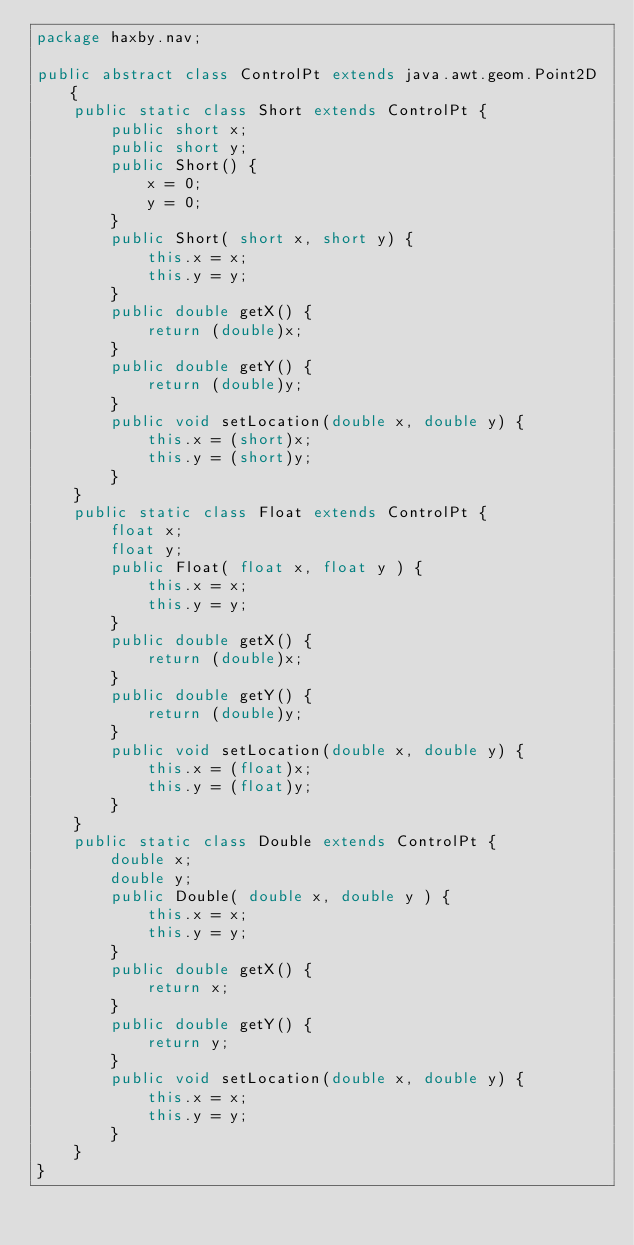Convert code to text. <code><loc_0><loc_0><loc_500><loc_500><_Java_>package haxby.nav;

public abstract class ControlPt extends java.awt.geom.Point2D {
	public static class Short extends ControlPt {
		public short x;
		public short y;
		public Short() {
			x = 0;
			y = 0;
		}
		public Short( short x, short y) {
			this.x = x;
			this.y = y;
		}
		public double getX() {
			return (double)x;
		}
		public double getY() {
			return (double)y;
		}
		public void setLocation(double x, double y) {
			this.x = (short)x;
			this.y = (short)y;
		}
	}
	public static class Float extends ControlPt {
		float x;
		float y;
		public Float( float x, float y ) {
			this.x = x;
			this.y = y;
		}
		public double getX() {
			return (double)x;
		}
		public double getY() {
			return (double)y;
		}
		public void setLocation(double x, double y) {
			this.x = (float)x;
			this.y = (float)y;
		}
	}
	public static class Double extends ControlPt {
		double x;
		double y;
		public Double( double x, double y ) {
			this.x = x;
			this.y = y;
		}
		public double getX() {
			return x;
		}
		public double getY() {
			return y;
		}
		public void setLocation(double x, double y) {
			this.x = x;
			this.y = y;
		}
	}
}
</code> 